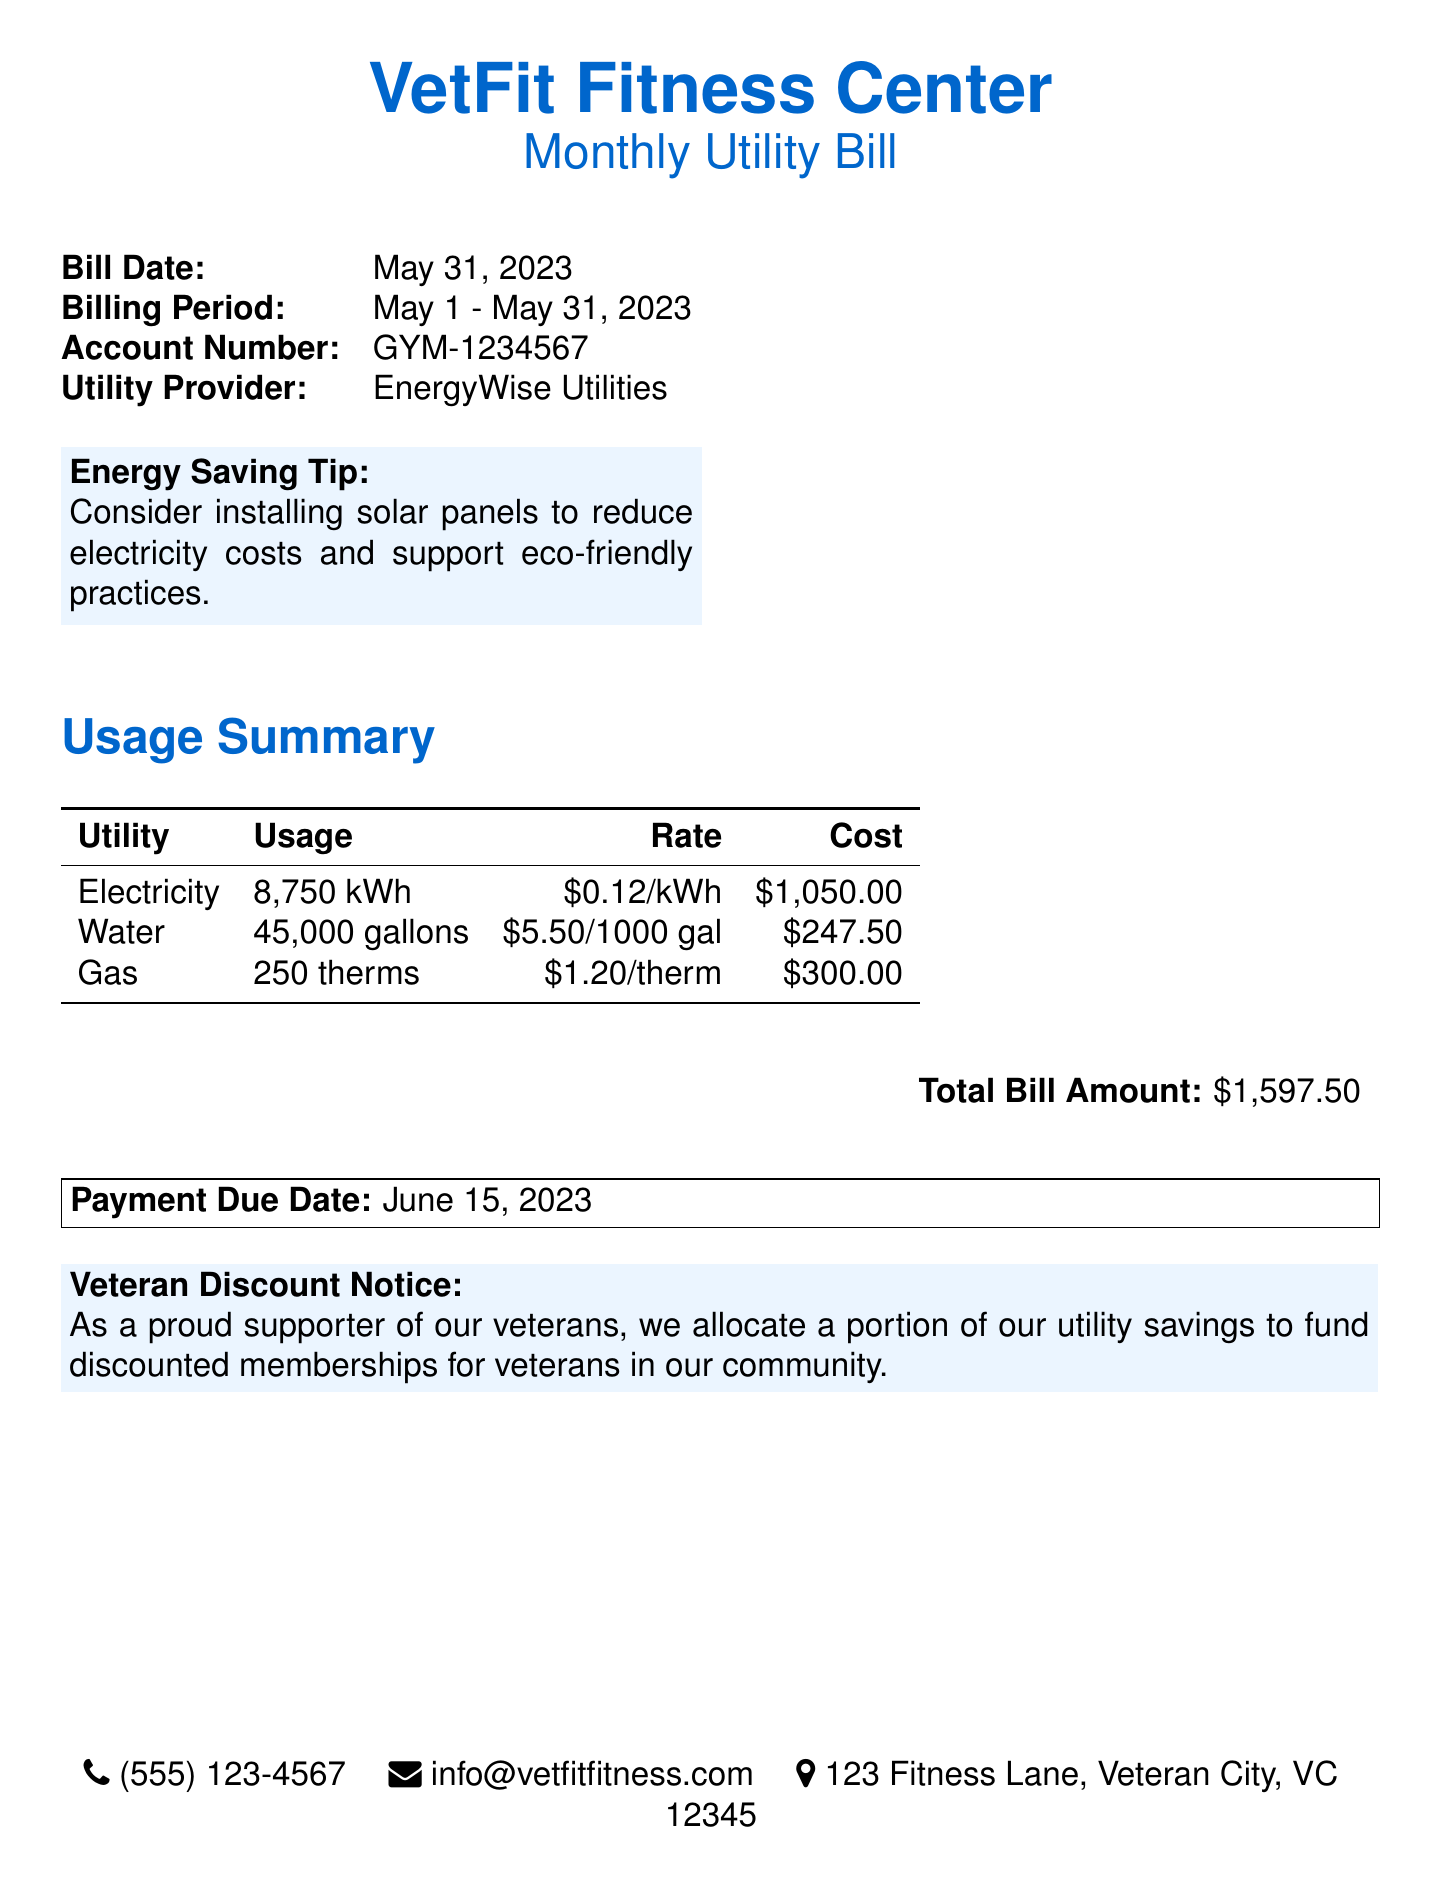What is the bill date? The bill date is mentioned at the top of the document.
Answer: May 31, 2023 What is the total utility bill amount? The total bill amount is stated in the summary section of the document.
Answer: $1,597.50 How many gallons of water were used? The water usage is detailed in the usage summary table.
Answer: 45,000 gallons What is the cost for electricity usage? The cost for electricity is found in the usage summary section of the document.
Answer: $1,050.00 What is the payment due date? The payment due date is specified at the bottom of the document.
Answer: June 15, 2023 How much gas was used during the billing period? The gas usage can be found in the usage summary table of the document.
Answer: 250 therms What is the rate for water? The rate for water is listed next to its usage and cost in the summary.
Answer: $5.50/1000 gal What utility provider is mentioned? The utility provider is stated at the beginning of the document.
Answer: EnergyWise Utilities How many kilowatt-hours of electricity were used? The electricity usage is specified in the usage summary of the document.
Answer: 8,750 kWh What action does the gym suggest for reducing electricity costs? The gym provides an energy-saving tip in the document.
Answer: Installing solar panels 